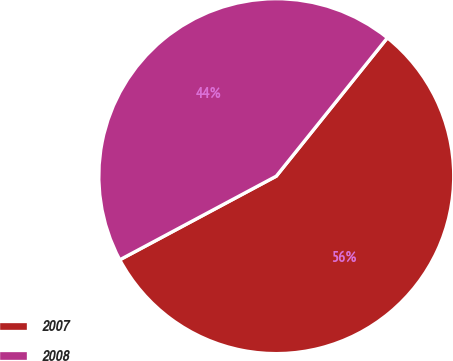<chart> <loc_0><loc_0><loc_500><loc_500><pie_chart><fcel>2007<fcel>2008<nl><fcel>56.42%<fcel>43.58%<nl></chart> 